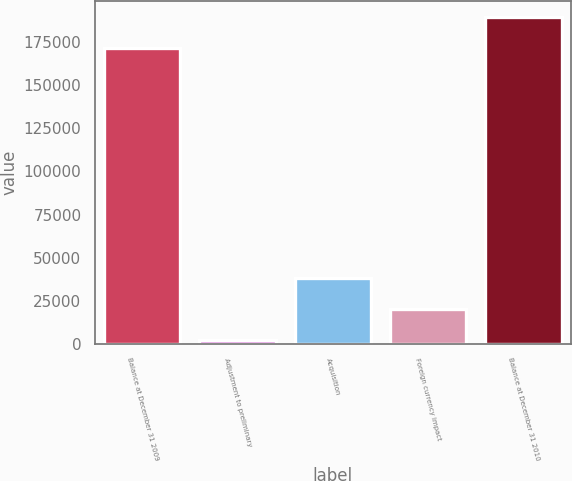<chart> <loc_0><loc_0><loc_500><loc_500><bar_chart><fcel>Balance at December 31 2009<fcel>Adjustment to preliminary<fcel>Acquisition<fcel>Foreign currency impact<fcel>Balance at December 31 2010<nl><fcel>171748<fcel>2368<fcel>38140<fcel>20254<fcel>189634<nl></chart> 